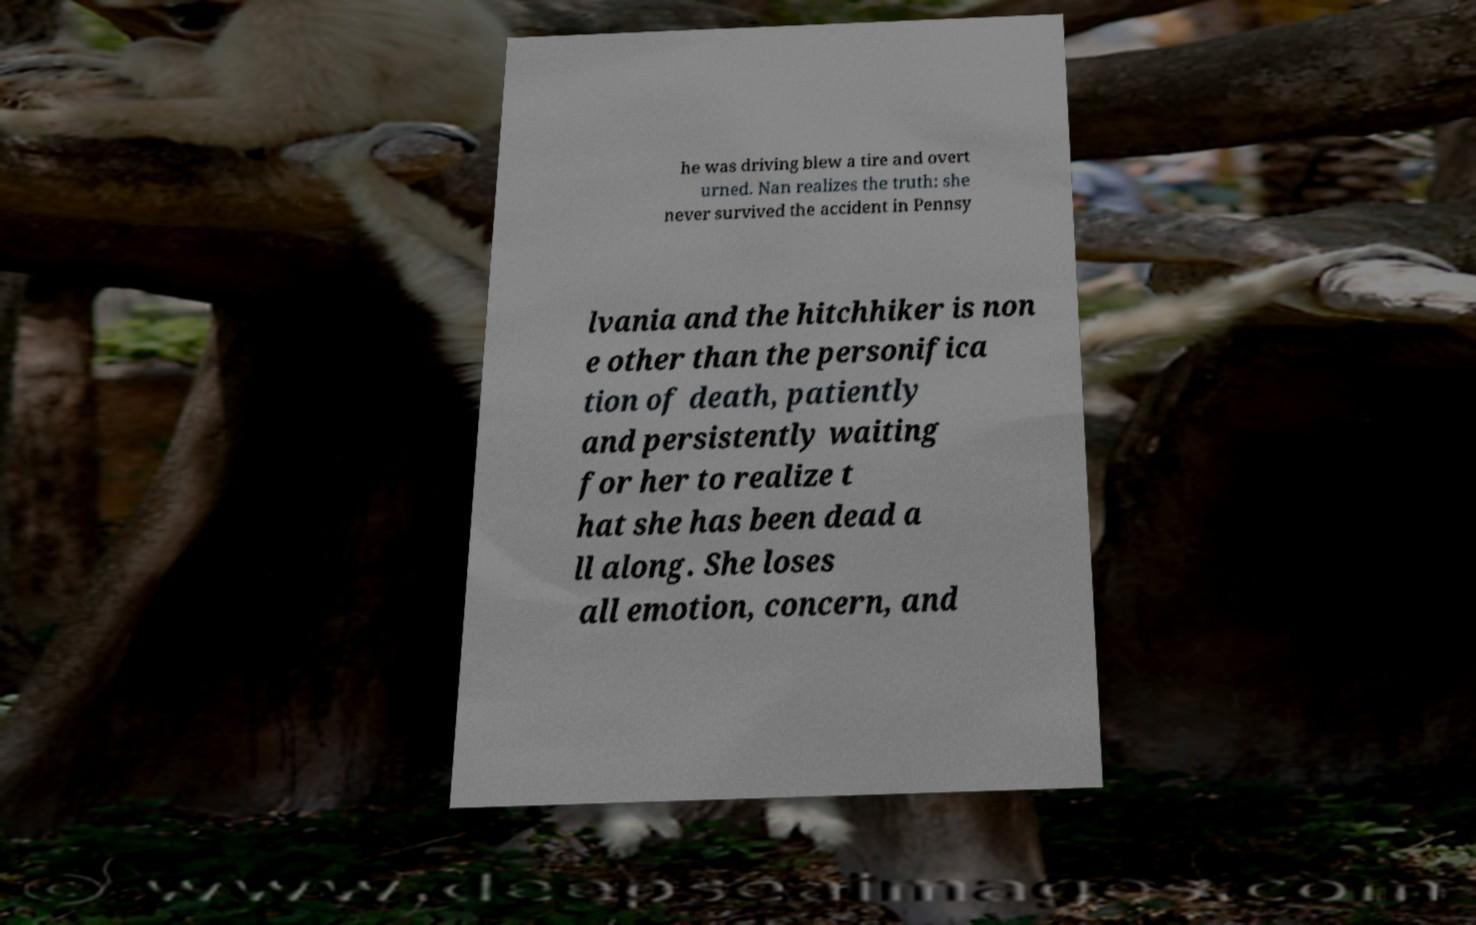There's text embedded in this image that I need extracted. Can you transcribe it verbatim? he was driving blew a tire and overt urned. Nan realizes the truth: she never survived the accident in Pennsy lvania and the hitchhiker is non e other than the personifica tion of death, patiently and persistently waiting for her to realize t hat she has been dead a ll along. She loses all emotion, concern, and 